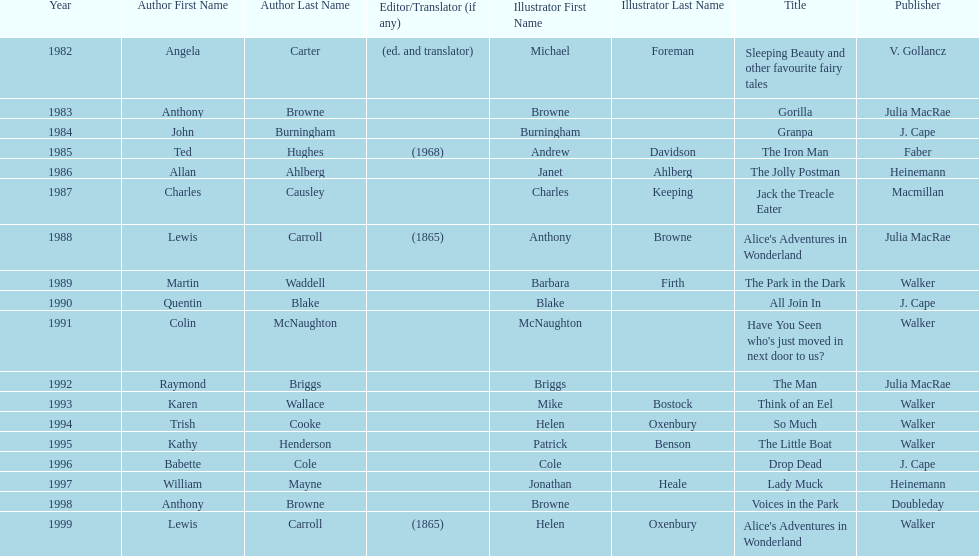Which title was after the year 1991 but before the year 1993? The Man. 